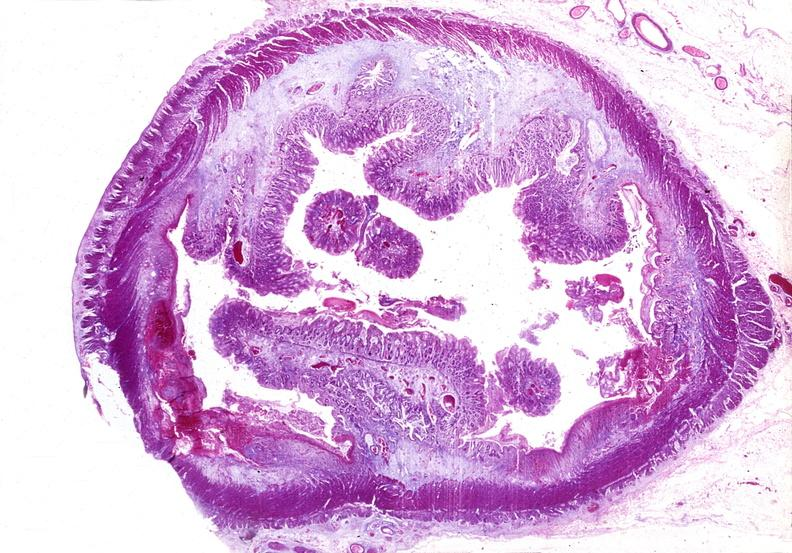what is present?
Answer the question using a single word or phrase. Gastrointestinal 